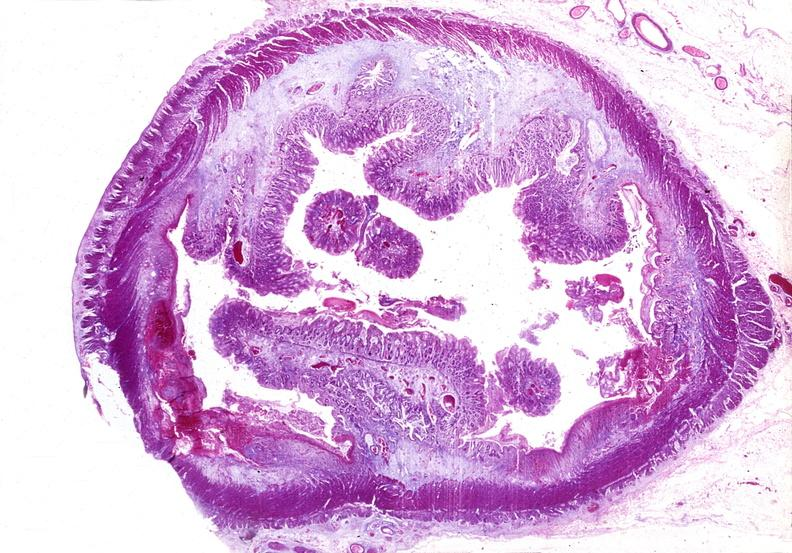what is present?
Answer the question using a single word or phrase. Gastrointestinal 